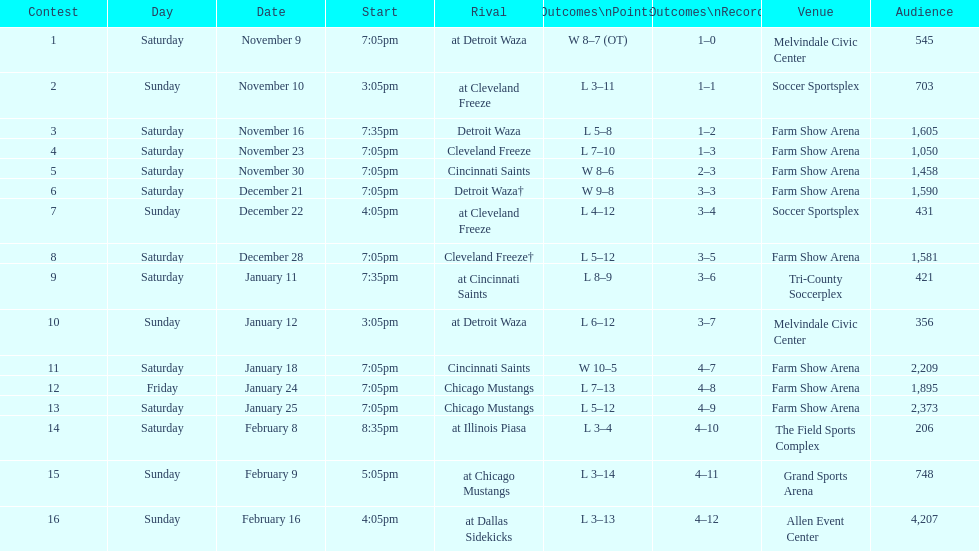What was the location before tri-county soccerplex? Farm Show Arena. 